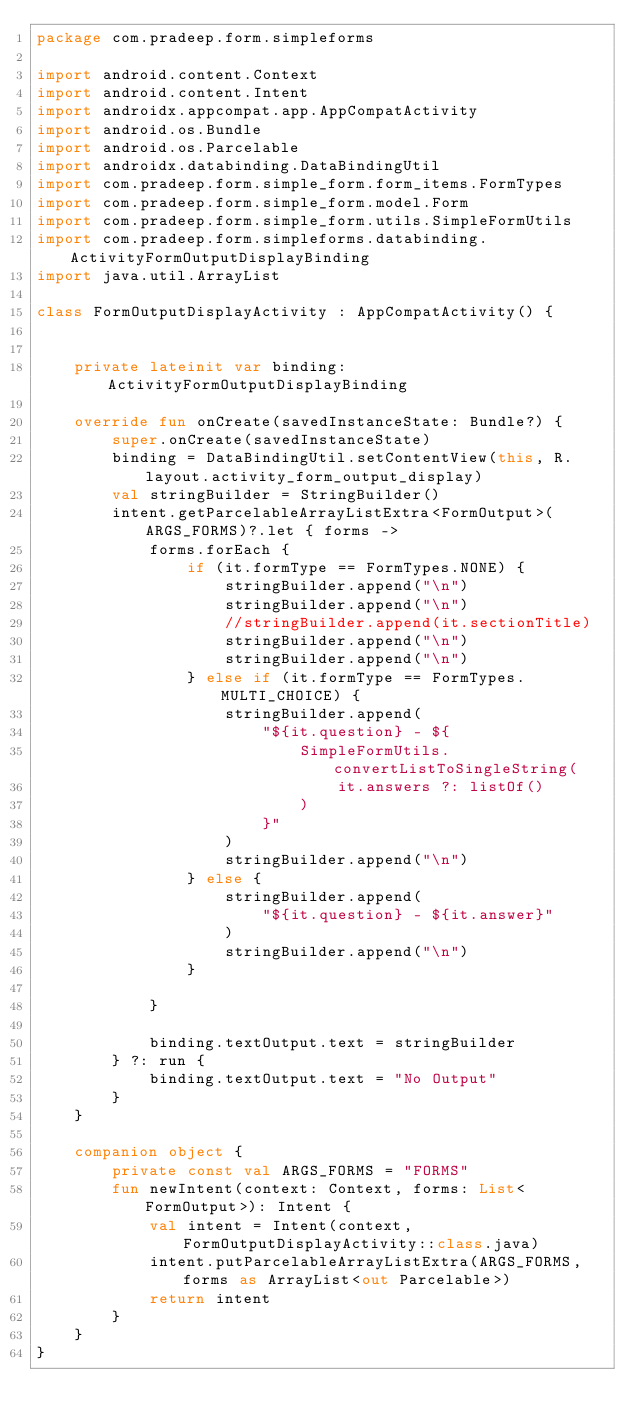<code> <loc_0><loc_0><loc_500><loc_500><_Kotlin_>package com.pradeep.form.simpleforms

import android.content.Context
import android.content.Intent
import androidx.appcompat.app.AppCompatActivity
import android.os.Bundle
import android.os.Parcelable
import androidx.databinding.DataBindingUtil
import com.pradeep.form.simple_form.form_items.FormTypes
import com.pradeep.form.simple_form.model.Form
import com.pradeep.form.simple_form.utils.SimpleFormUtils
import com.pradeep.form.simpleforms.databinding.ActivityFormOutputDisplayBinding
import java.util.ArrayList

class FormOutputDisplayActivity : AppCompatActivity() {


    private lateinit var binding: ActivityFormOutputDisplayBinding

    override fun onCreate(savedInstanceState: Bundle?) {
        super.onCreate(savedInstanceState)
        binding = DataBindingUtil.setContentView(this, R.layout.activity_form_output_display)
        val stringBuilder = StringBuilder()
        intent.getParcelableArrayListExtra<FormOutput>(ARGS_FORMS)?.let { forms ->
            forms.forEach {
                if (it.formType == FormTypes.NONE) {
                    stringBuilder.append("\n")
                    stringBuilder.append("\n")
                    //stringBuilder.append(it.sectionTitle)
                    stringBuilder.append("\n")
                    stringBuilder.append("\n")
                } else if (it.formType == FormTypes.MULTI_CHOICE) {
                    stringBuilder.append(
                        "${it.question} - ${
                            SimpleFormUtils.convertListToSingleString(
                                it.answers ?: listOf()
                            )
                        }"
                    )
                    stringBuilder.append("\n")
                } else {
                    stringBuilder.append(
                        "${it.question} - ${it.answer}"
                    )
                    stringBuilder.append("\n")
                }

            }

            binding.textOutput.text = stringBuilder
        } ?: run {
            binding.textOutput.text = "No Output"
        }
    }

    companion object {
        private const val ARGS_FORMS = "FORMS"
        fun newIntent(context: Context, forms: List<FormOutput>): Intent {
            val intent = Intent(context, FormOutputDisplayActivity::class.java)
            intent.putParcelableArrayListExtra(ARGS_FORMS, forms as ArrayList<out Parcelable>)
            return intent
        }
    }
}</code> 